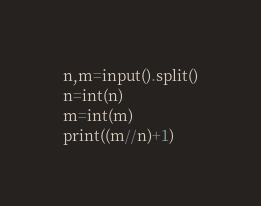<code> <loc_0><loc_0><loc_500><loc_500><_Python_>n,m=input().split()
n=int(n)
m=int(m)
print((m//n)+1)</code> 